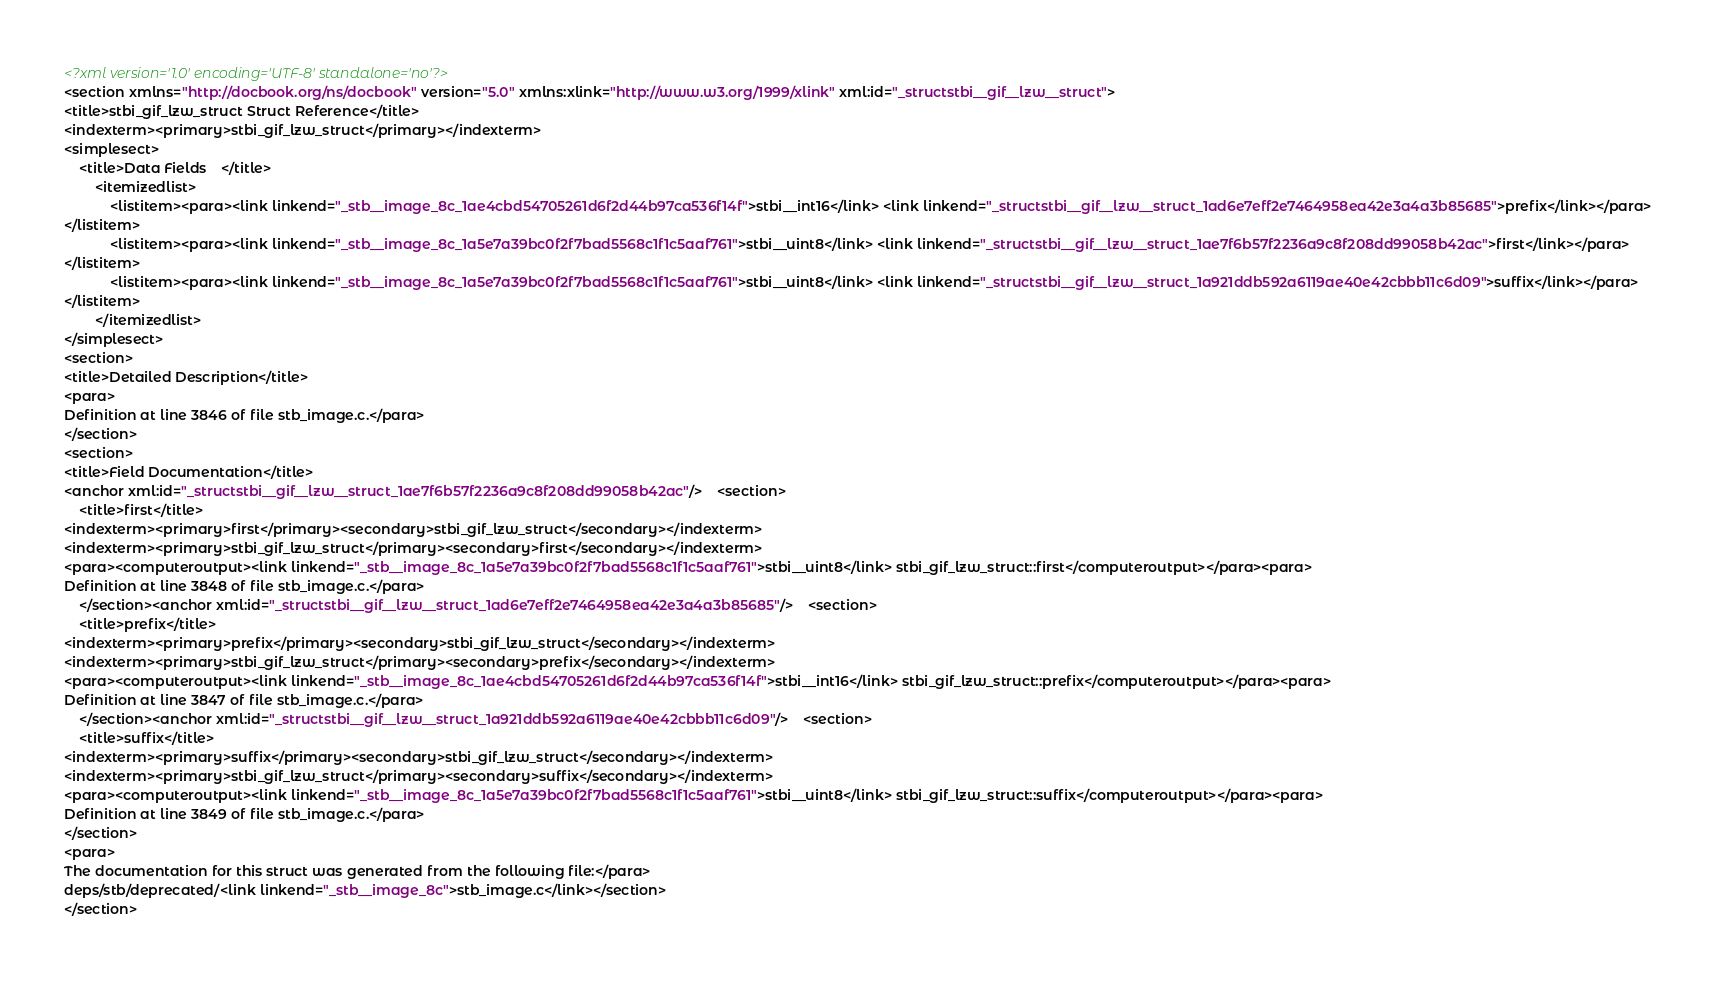<code> <loc_0><loc_0><loc_500><loc_500><_XML_><?xml version='1.0' encoding='UTF-8' standalone='no'?>
<section xmlns="http://docbook.org/ns/docbook" version="5.0" xmlns:xlink="http://www.w3.org/1999/xlink" xml:id="_structstbi__gif__lzw__struct">
<title>stbi_gif_lzw_struct Struct Reference</title>
<indexterm><primary>stbi_gif_lzw_struct</primary></indexterm>
<simplesect>
    <title>Data Fields    </title>
        <itemizedlist>
            <listitem><para><link linkend="_stb__image_8c_1ae4cbd54705261d6f2d44b97ca536f14f">stbi__int16</link> <link linkend="_structstbi__gif__lzw__struct_1ad6e7eff2e7464958ea42e3a4a3b85685">prefix</link></para>
</listitem>
            <listitem><para><link linkend="_stb__image_8c_1a5e7a39bc0f2f7bad5568c1f1c5aaf761">stbi__uint8</link> <link linkend="_structstbi__gif__lzw__struct_1ae7f6b57f2236a9c8f208dd99058b42ac">first</link></para>
</listitem>
            <listitem><para><link linkend="_stb__image_8c_1a5e7a39bc0f2f7bad5568c1f1c5aaf761">stbi__uint8</link> <link linkend="_structstbi__gif__lzw__struct_1a921ddb592a6119ae40e42cbbb11c6d09">suffix</link></para>
</listitem>
        </itemizedlist>
</simplesect>
<section>
<title>Detailed Description</title>
<para>
Definition at line 3846 of file stb_image.c.</para>
</section>
<section>
<title>Field Documentation</title>
<anchor xml:id="_structstbi__gif__lzw__struct_1ae7f6b57f2236a9c8f208dd99058b42ac"/>    <section>
    <title>first</title>
<indexterm><primary>first</primary><secondary>stbi_gif_lzw_struct</secondary></indexterm>
<indexterm><primary>stbi_gif_lzw_struct</primary><secondary>first</secondary></indexterm>
<para><computeroutput><link linkend="_stb__image_8c_1a5e7a39bc0f2f7bad5568c1f1c5aaf761">stbi__uint8</link> stbi_gif_lzw_struct::first</computeroutput></para><para>
Definition at line 3848 of file stb_image.c.</para>
    </section><anchor xml:id="_structstbi__gif__lzw__struct_1ad6e7eff2e7464958ea42e3a4a3b85685"/>    <section>
    <title>prefix</title>
<indexterm><primary>prefix</primary><secondary>stbi_gif_lzw_struct</secondary></indexterm>
<indexterm><primary>stbi_gif_lzw_struct</primary><secondary>prefix</secondary></indexterm>
<para><computeroutput><link linkend="_stb__image_8c_1ae4cbd54705261d6f2d44b97ca536f14f">stbi__int16</link> stbi_gif_lzw_struct::prefix</computeroutput></para><para>
Definition at line 3847 of file stb_image.c.</para>
    </section><anchor xml:id="_structstbi__gif__lzw__struct_1a921ddb592a6119ae40e42cbbb11c6d09"/>    <section>
    <title>suffix</title>
<indexterm><primary>suffix</primary><secondary>stbi_gif_lzw_struct</secondary></indexterm>
<indexterm><primary>stbi_gif_lzw_struct</primary><secondary>suffix</secondary></indexterm>
<para><computeroutput><link linkend="_stb__image_8c_1a5e7a39bc0f2f7bad5568c1f1c5aaf761">stbi__uint8</link> stbi_gif_lzw_struct::suffix</computeroutput></para><para>
Definition at line 3849 of file stb_image.c.</para>
</section>
<para>
The documentation for this struct was generated from the following file:</para>
deps/stb/deprecated/<link linkend="_stb__image_8c">stb_image.c</link></section>
</section>
</code> 